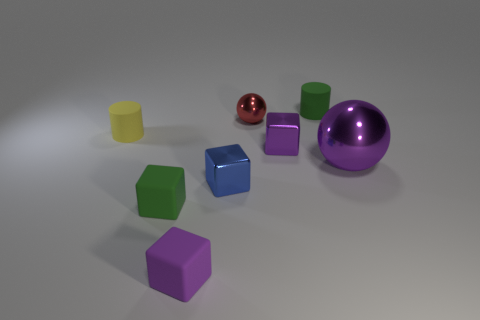Add 2 small metallic spheres. How many objects exist? 10 Subtract all cylinders. How many objects are left? 6 Subtract all rubber cubes. Subtract all red shiny objects. How many objects are left? 5 Add 4 big metal spheres. How many big metal spheres are left? 5 Add 5 red matte objects. How many red matte objects exist? 5 Subtract 0 red cubes. How many objects are left? 8 